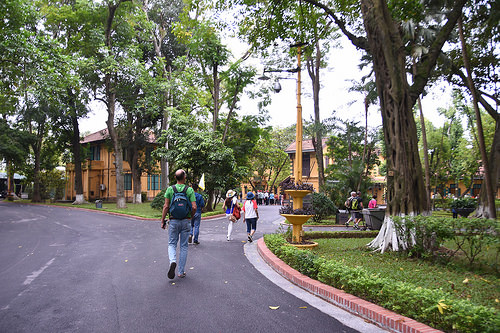<image>
Can you confirm if the people is in the grass? No. The people is not contained within the grass. These objects have a different spatial relationship. 